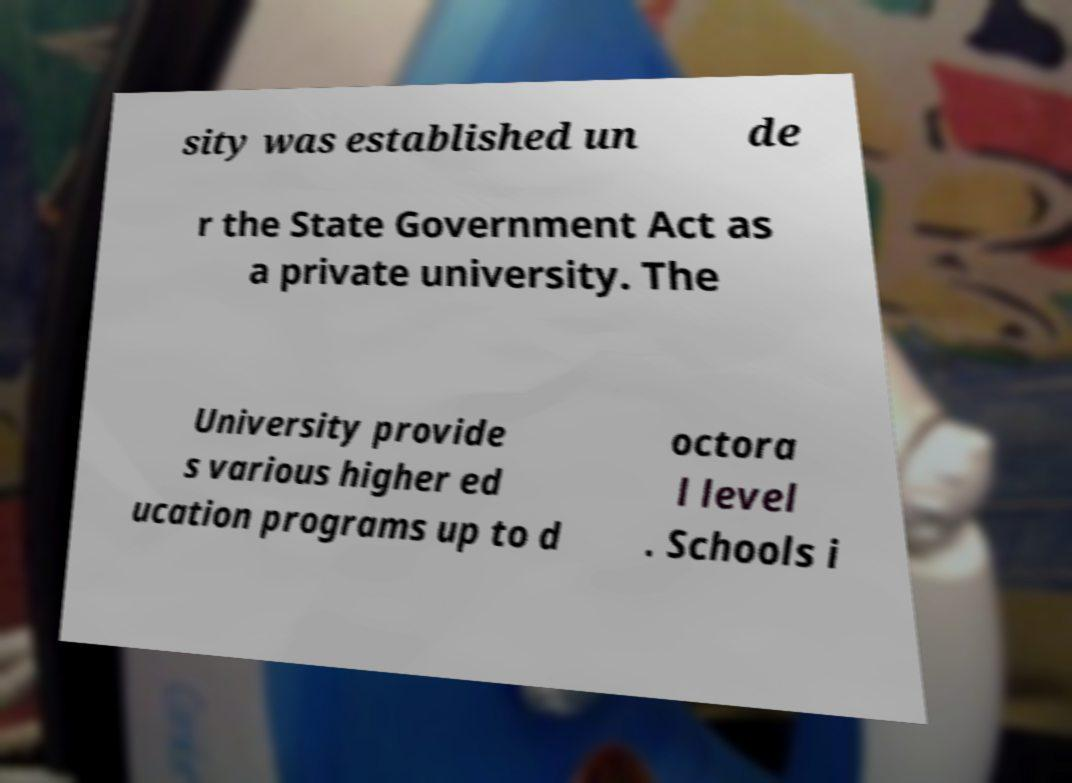There's text embedded in this image that I need extracted. Can you transcribe it verbatim? sity was established un de r the State Government Act as a private university. The University provide s various higher ed ucation programs up to d octora l level . Schools i 